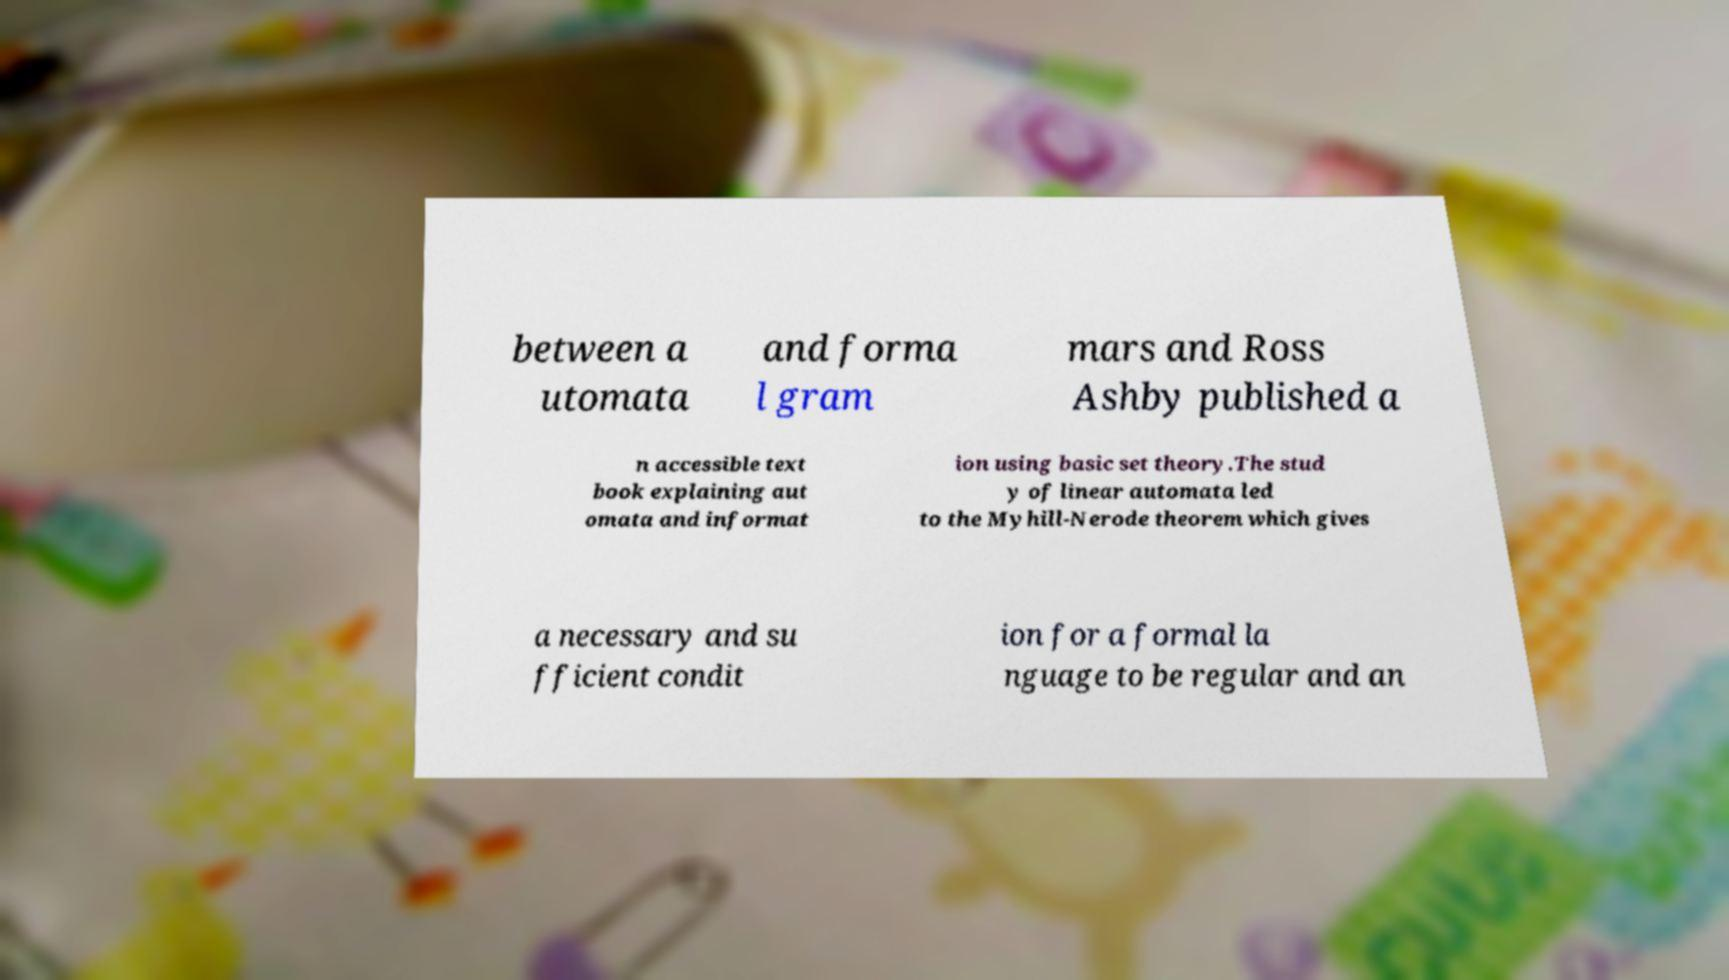Please read and relay the text visible in this image. What does it say? between a utomata and forma l gram mars and Ross Ashby published a n accessible text book explaining aut omata and informat ion using basic set theory.The stud y of linear automata led to the Myhill-Nerode theorem which gives a necessary and su fficient condit ion for a formal la nguage to be regular and an 